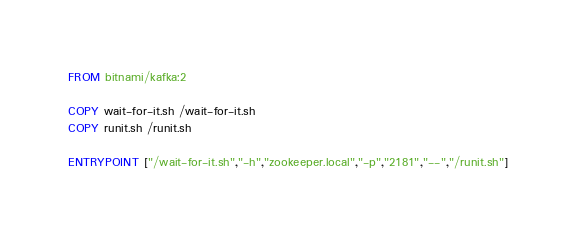<code> <loc_0><loc_0><loc_500><loc_500><_Dockerfile_>FROM bitnami/kafka:2

COPY wait-for-it.sh /wait-for-it.sh
COPY runit.sh /runit.sh

ENTRYPOINT ["/wait-for-it.sh","-h","zookeeper.local","-p","2181","--","/runit.sh"]
</code> 